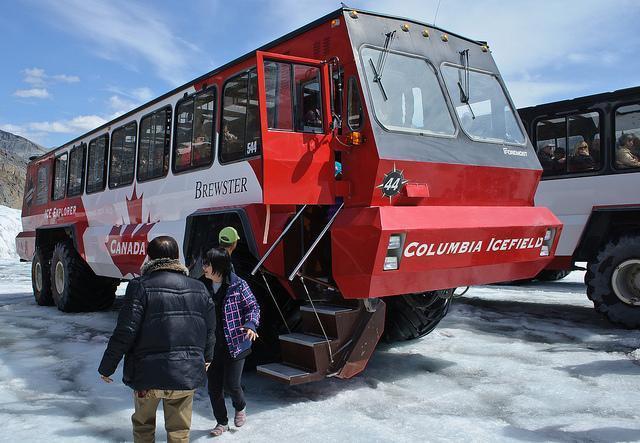How many people are there?
Give a very brief answer. 2. How many buses are there?
Give a very brief answer. 2. 